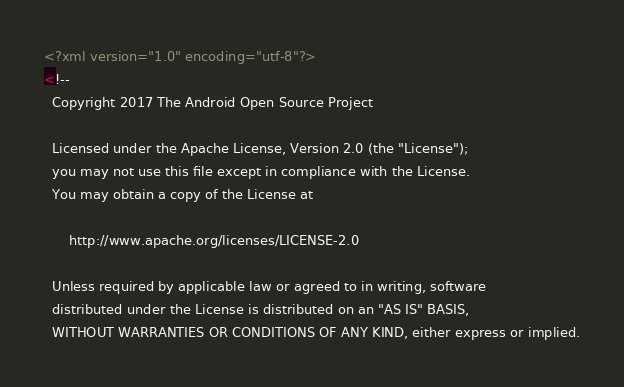<code> <loc_0><loc_0><loc_500><loc_500><_XML_><?xml version="1.0" encoding="utf-8"?>
<!--
  Copyright 2017 The Android Open Source Project

  Licensed under the Apache License, Version 2.0 (the "License");
  you may not use this file except in compliance with the License.
  You may obtain a copy of the License at

      http://www.apache.org/licenses/LICENSE-2.0

  Unless required by applicable law or agreed to in writing, software
  distributed under the License is distributed on an "AS IS" BASIS,
  WITHOUT WARRANTIES OR CONDITIONS OF ANY KIND, either express or implied.</code> 